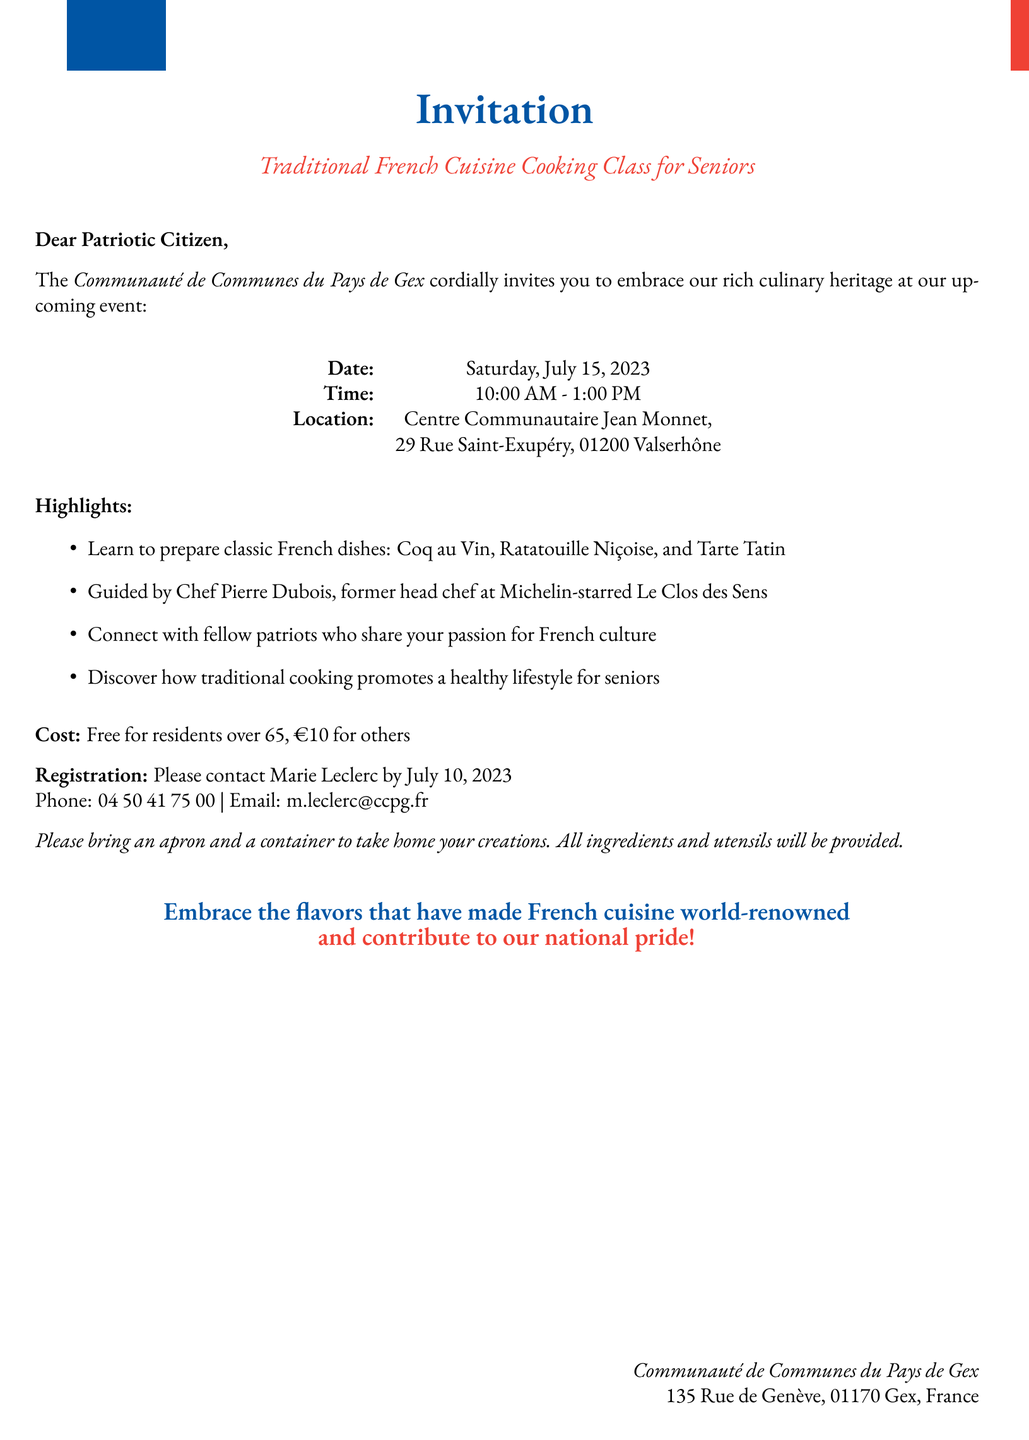What is the title of the event? The title of the event is stated as "Traditional French Cuisine Cooking Class for Seniors."
Answer: Traditional French Cuisine Cooking Class for Seniors Who is the instructor? The document mentions the instructor's name and background, identifying him as the head chef at a Michelin-starred restaurant.
Answer: Chef Pierre Dubois What date is the cooking class scheduled? The document specifies the date of the event clearly.
Answer: July 15, 2023 How much does the class cost for residents over 65? The document indicates the cost explicitly for this specific group of attendees.
Answer: Free What is the location of the cooking class? The document includes the address where the event will take place.
Answer: Centre Communautaire Jean Monnet, 29 Rue Saint-Exupéry, 01200 Valserhône What should participants bring to the class? The document provides specific items that attendees are advised to bring along.
Answer: An apron and a container When is the registration deadline? The document clearly states the last date for signing up for the class.
Answer: July 10, 2023 How many featured recipes are highlighted in the document? The document lists a specific number of recipes that will be covered in the class.
Answer: Three What is the main focus of the cooking class? The document describes the overall purpose and theme of the cooking class.
Answer: Traditional French dishes 